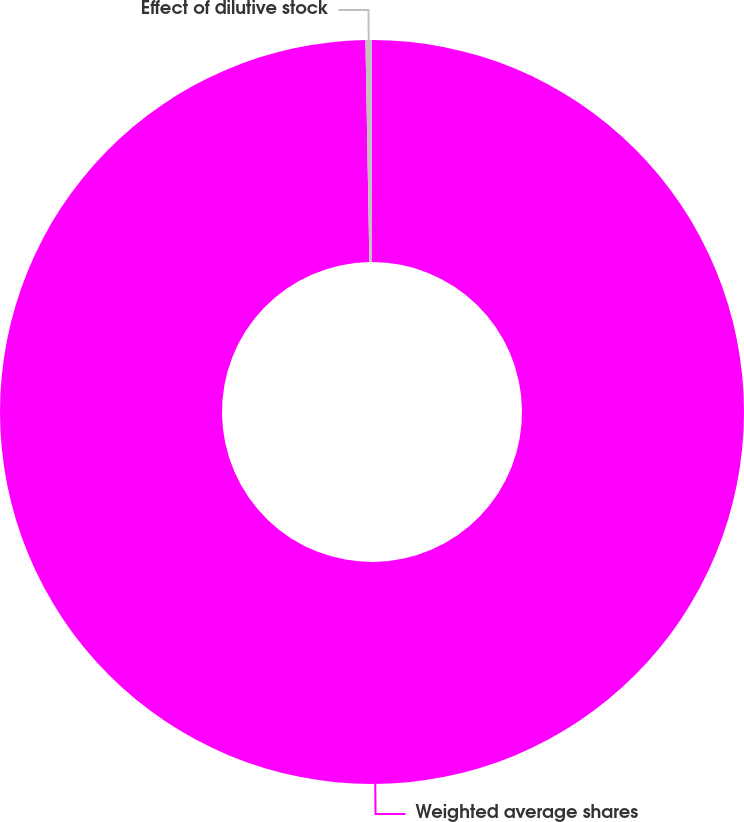Convert chart to OTSL. <chart><loc_0><loc_0><loc_500><loc_500><pie_chart><fcel>Weighted average shares<fcel>Effect of dilutive stock<nl><fcel>99.72%<fcel>0.28%<nl></chart> 